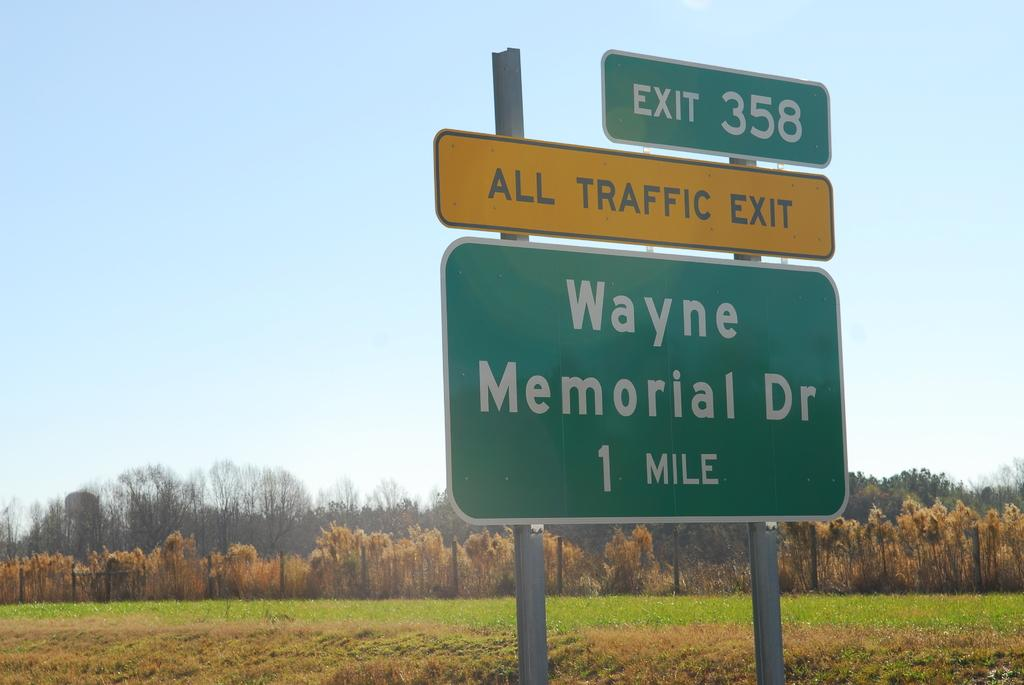<image>
Render a clear and concise summary of the photo. A street sign by a rural field says All Traffic Exit. 